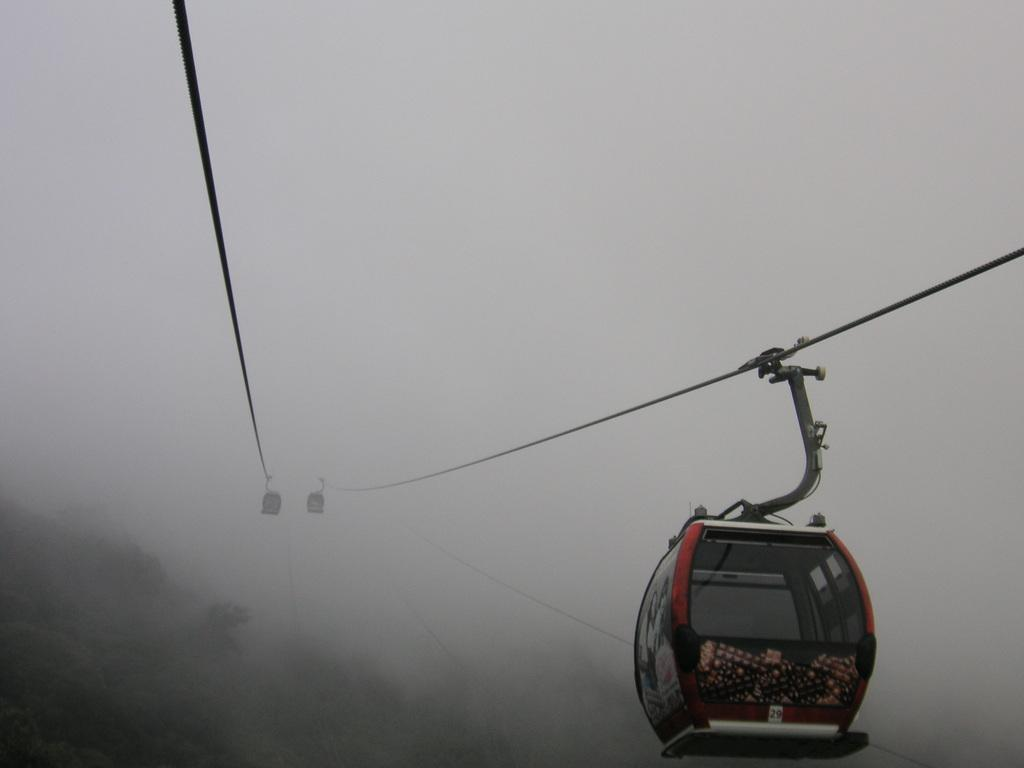What is the main subject of the picture? The main subject of the picture is a ropeway. How is the ropeway affected by the weather in the image? The ropeway is covered in snow, indicating that it is likely cold and possibly snowing. What can be seen below the ropeway? There are trees below the ropeway. What type of crime is being committed near the ropeway in the image? There is no indication of any crime being committed in the image; it features a snow-covered ropeway with trees below. How many toes can be seen on the person standing near the ropeway? There is no person visible in the image, so it is impossible to determine the number of toes present. 